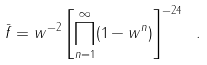<formula> <loc_0><loc_0><loc_500><loc_500>\bar { f } = w ^ { - 2 } \left [ \prod _ { n = 1 } ^ { \infty } ( 1 - w ^ { n } ) \right ] ^ { - 2 4 } \ .</formula> 